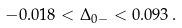Convert formula to latex. <formula><loc_0><loc_0><loc_500><loc_500>- 0 . 0 1 8 < \Delta _ { 0 - } < 0 . 0 9 3 \, .</formula> 